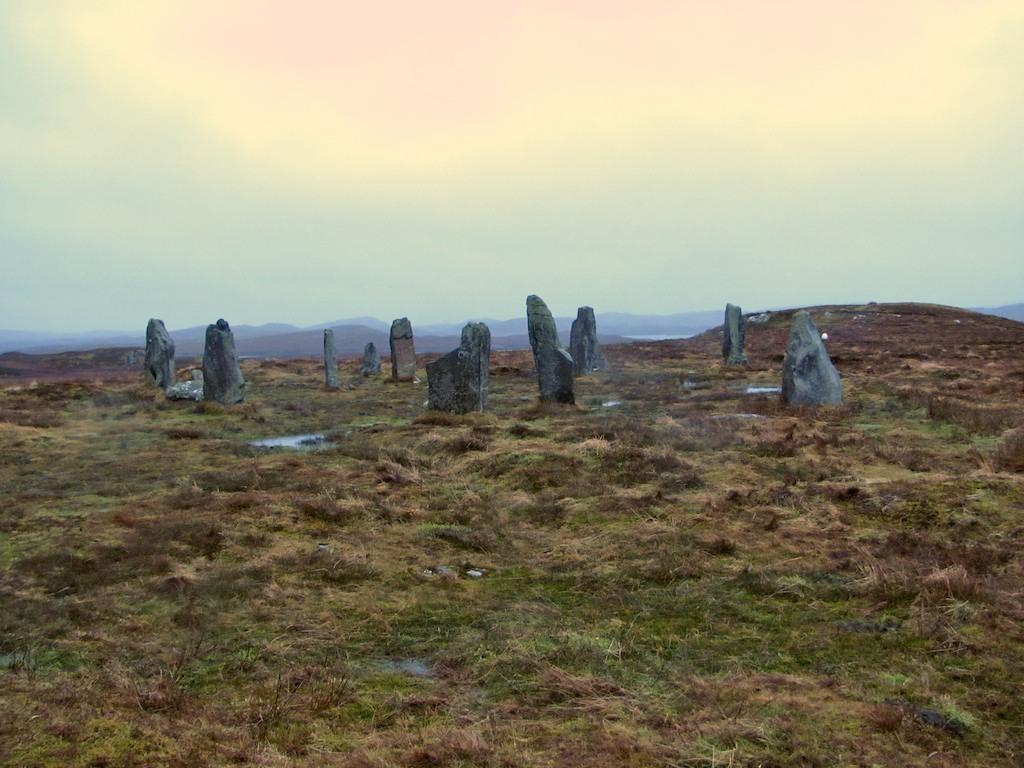What type of terrain is visible on the ground in the image? There are stones and grass on the ground in the image. What can be seen in the distance in the image? There are mountains in the background of the image. What is visible in the sky in the background of the image? There are clouds in the sky in the background of the image. What type of suit is the laborer wearing in the image? There is no laborer or suit present in the image. How does the spade help the laborer in the image? There is no laborer or spade present in the image. 